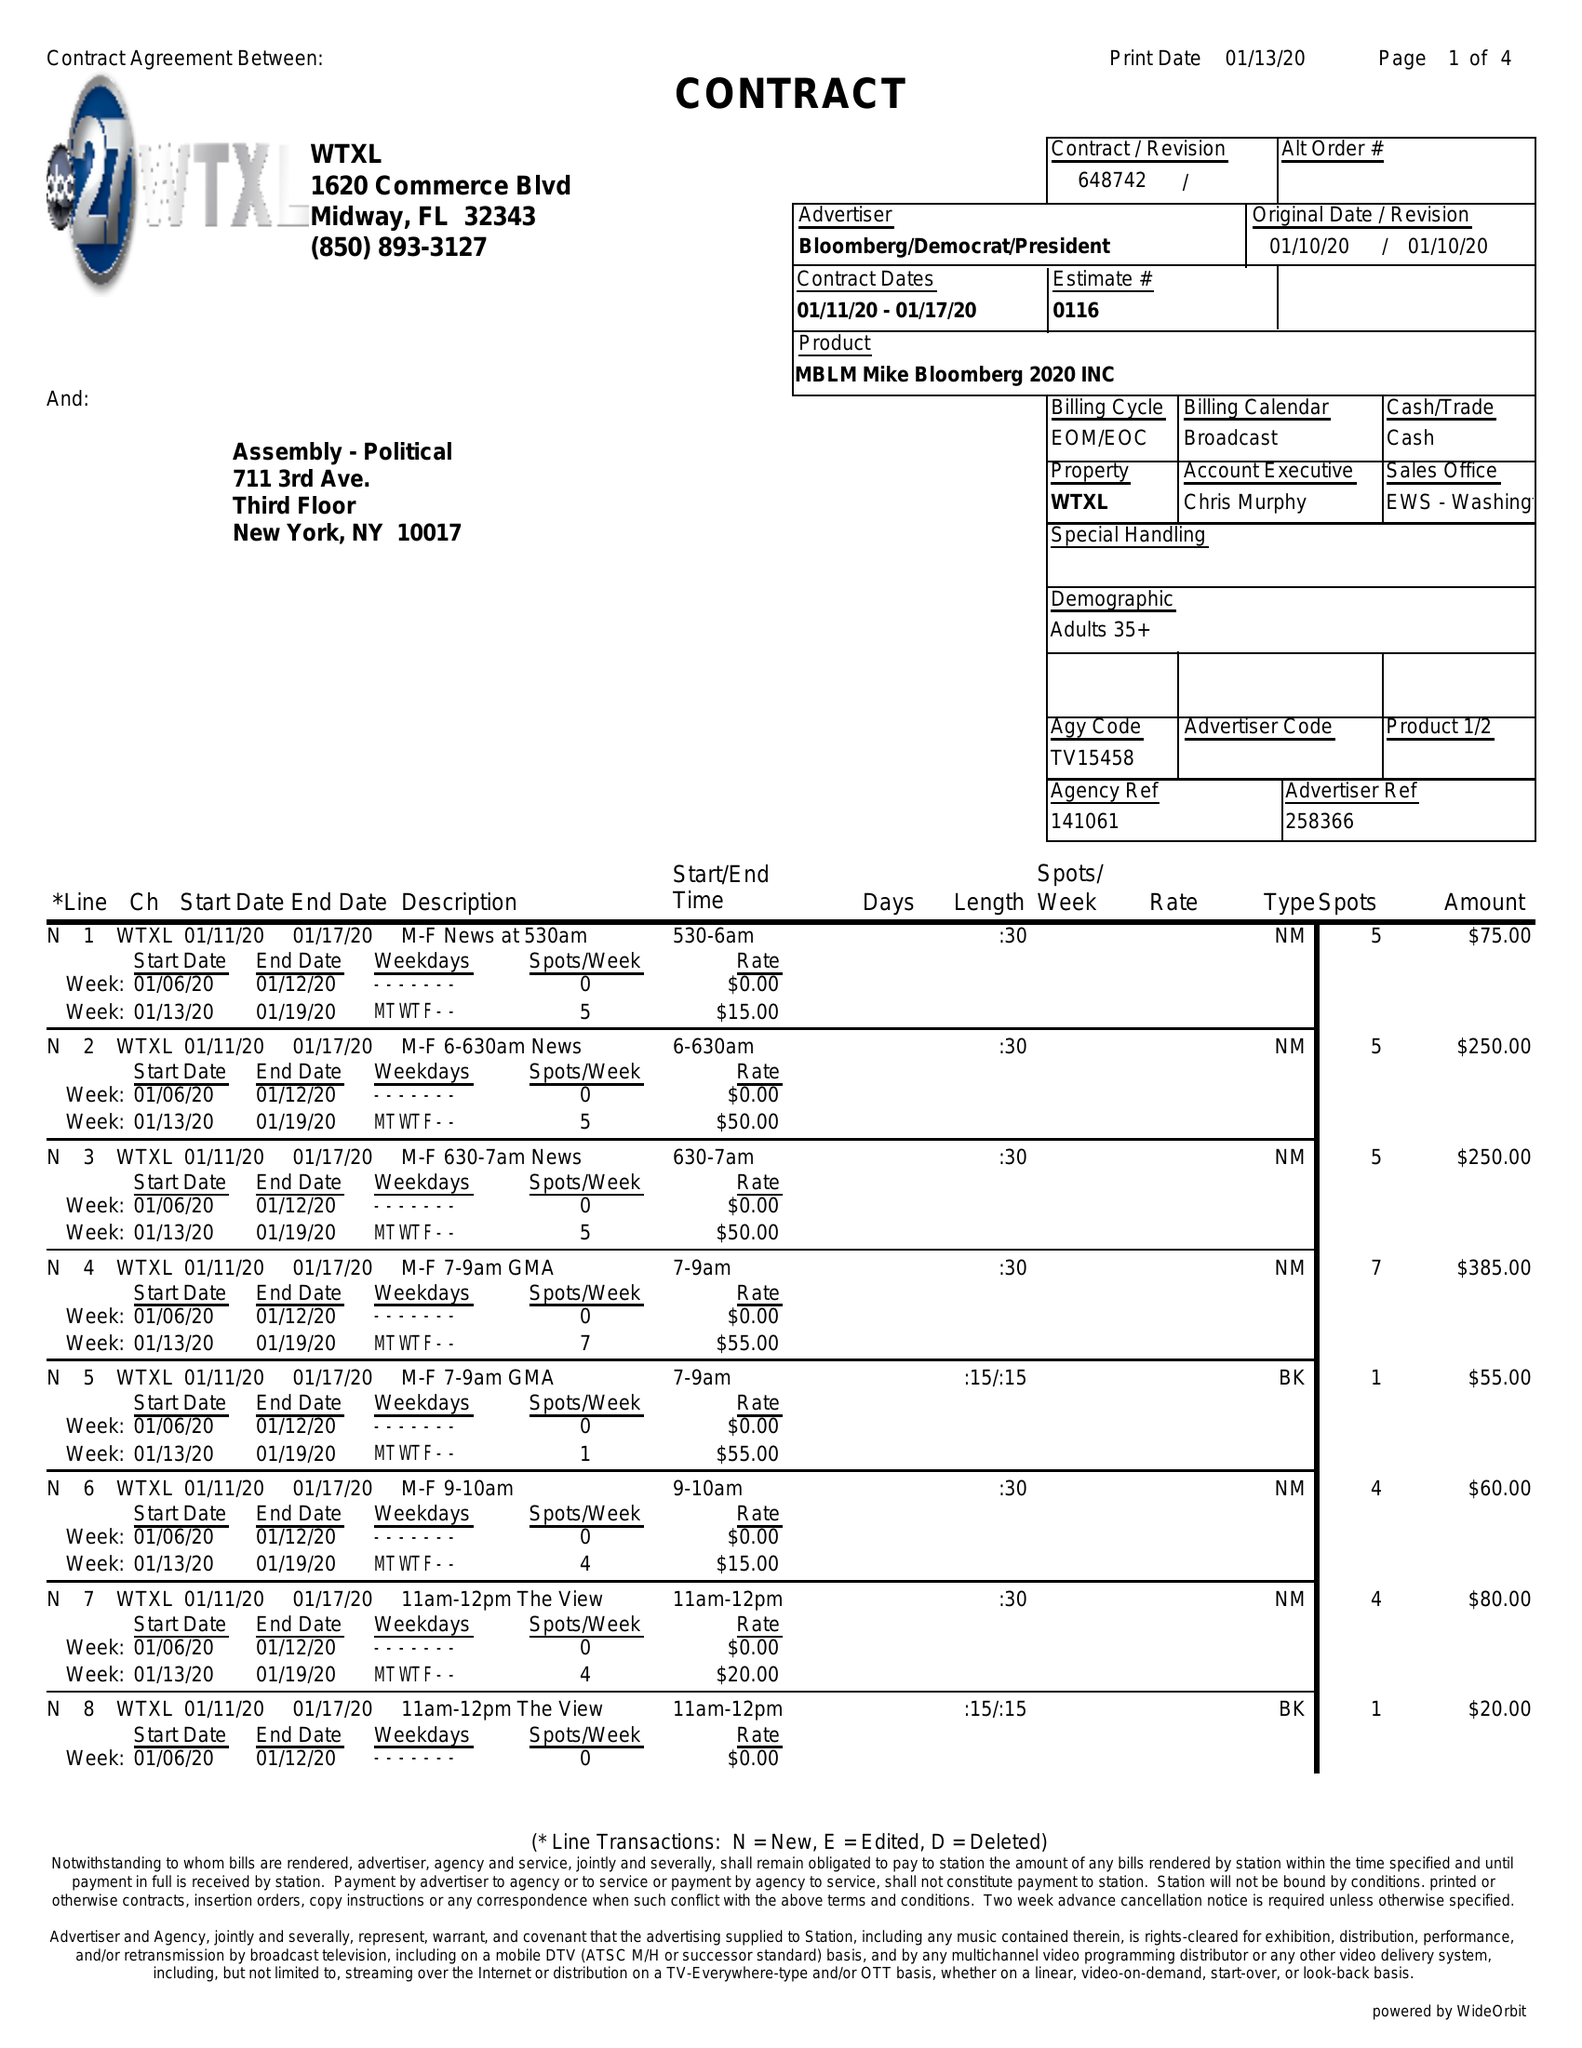What is the value for the flight_from?
Answer the question using a single word or phrase. 01/11/20 